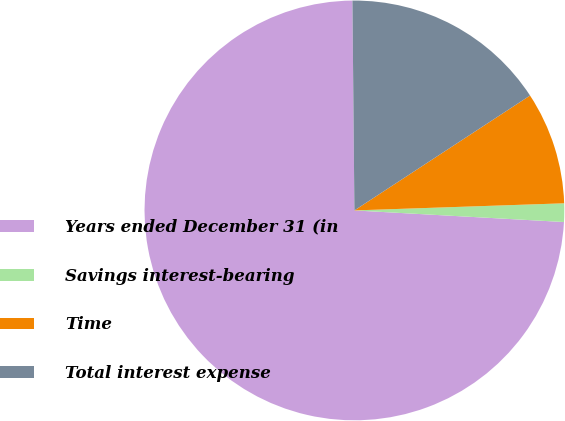Convert chart. <chart><loc_0><loc_0><loc_500><loc_500><pie_chart><fcel>Years ended December 31 (in<fcel>Savings interest-bearing<fcel>Time<fcel>Total interest expense<nl><fcel>73.97%<fcel>1.42%<fcel>8.68%<fcel>15.93%<nl></chart> 